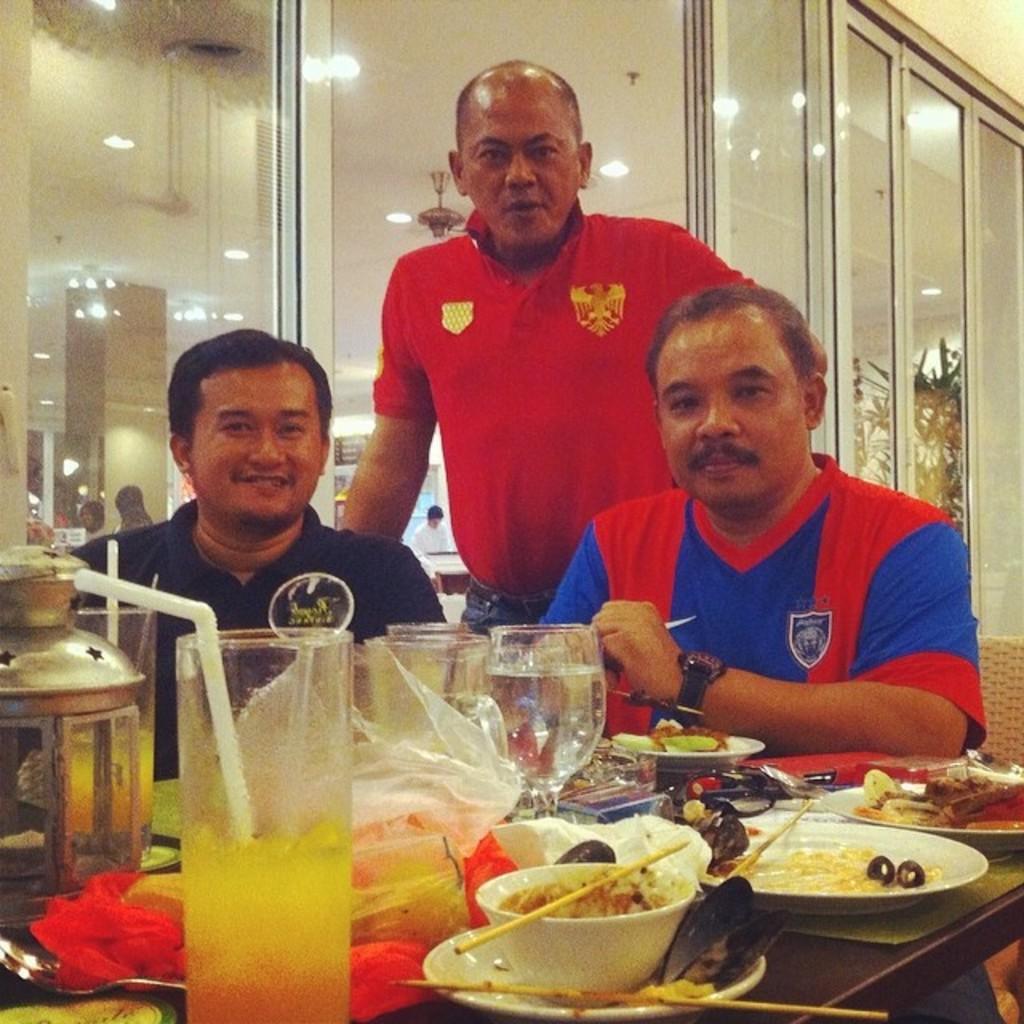Could you give a brief overview of what you see in this image? Here we can see three persons. There is a table. On the table there are plates, bowls, chopsticks, glasses, spoons, and food. In the background we can see glasses, lights, pillar, ceiling, wall, and a person. 